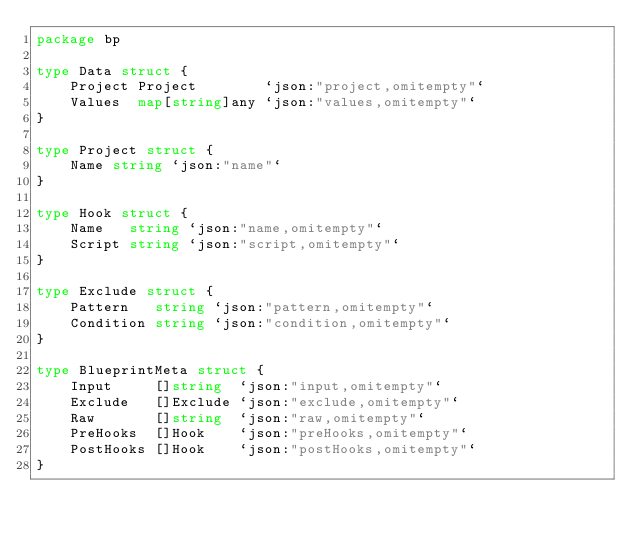Convert code to text. <code><loc_0><loc_0><loc_500><loc_500><_Go_>package bp

type Data struct {
	Project Project        `json:"project,omitempty"`
	Values  map[string]any `json:"values,omitempty"`
}

type Project struct {
	Name string `json:"name"`
}

type Hook struct {
	Name   string `json:"name,omitempty"`
	Script string `json:"script,omitempty"`
}

type Exclude struct {
	Pattern   string `json:"pattern,omitempty"`
	Condition string `json:"condition,omitempty"`
}

type BlueprintMeta struct {
	Input     []string  `json:"input,omitempty"`
	Exclude   []Exclude `json:"exclude,omitempty"`
	Raw       []string  `json:"raw,omitempty"`
	PreHooks  []Hook    `json:"preHooks,omitempty"`
	PostHooks []Hook    `json:"postHooks,omitempty"`
}
</code> 